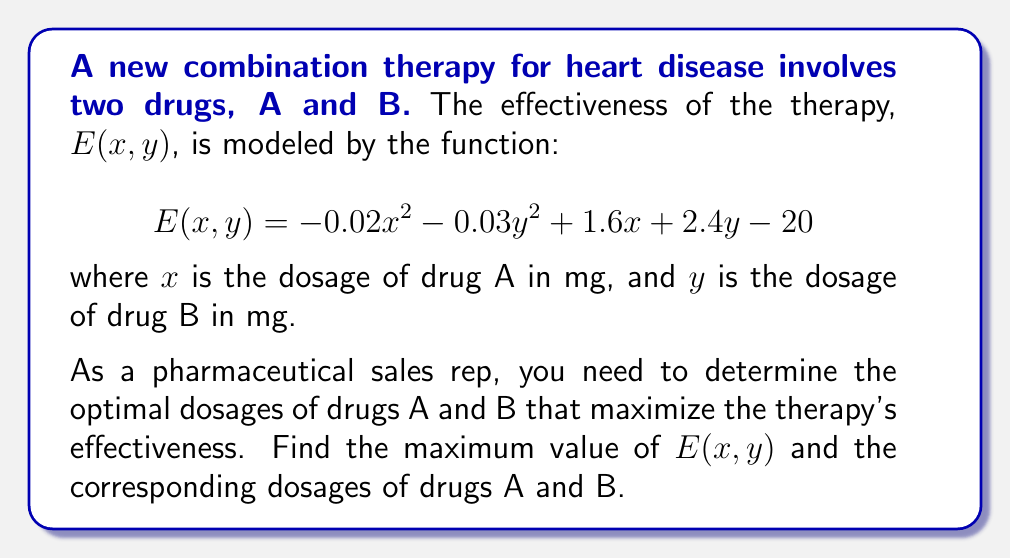Solve this math problem. To find the maximum effectiveness point, we need to follow these steps:

1) Find the partial derivatives of E with respect to x and y:
   $$\frac{\partial E}{\partial x} = -0.04x + 1.6$$
   $$\frac{\partial E}{\partial y} = -0.06y + 2.4$$

2) Set both partial derivatives to zero to find the critical point:
   $$-0.04x + 1.6 = 0$$
   $$-0.06y + 2.4 = 0$$

3) Solve these equations:
   $$x = \frac{1.6}{0.04} = 40$$
   $$y = \frac{2.4}{0.06} = 40$$

4) Verify that this critical point is a maximum by checking the second partial derivatives:
   $$\frac{\partial^2 E}{\partial x^2} = -0.04 < 0$$
   $$\frac{\partial^2 E}{\partial y^2} = -0.06 < 0$$
   
   Since both second partial derivatives are negative, this critical point is a maximum.

5) Calculate the maximum value of E by substituting x = 40 and y = 40 into the original function:
   $$E(40, 40) = -0.02(40)^2 - 0.03(40)^2 + 1.6(40) + 2.4(40) - 20$$
   $$= -32 - 48 + 64 + 96 - 20 = 60$$

Therefore, the maximum effectiveness is achieved when drug A is administered at 40 mg and drug B at 40 mg, resulting in an effectiveness score of 60.
Answer: Maximum E(x,y) = 60 at x = 40 mg, y = 40 mg 